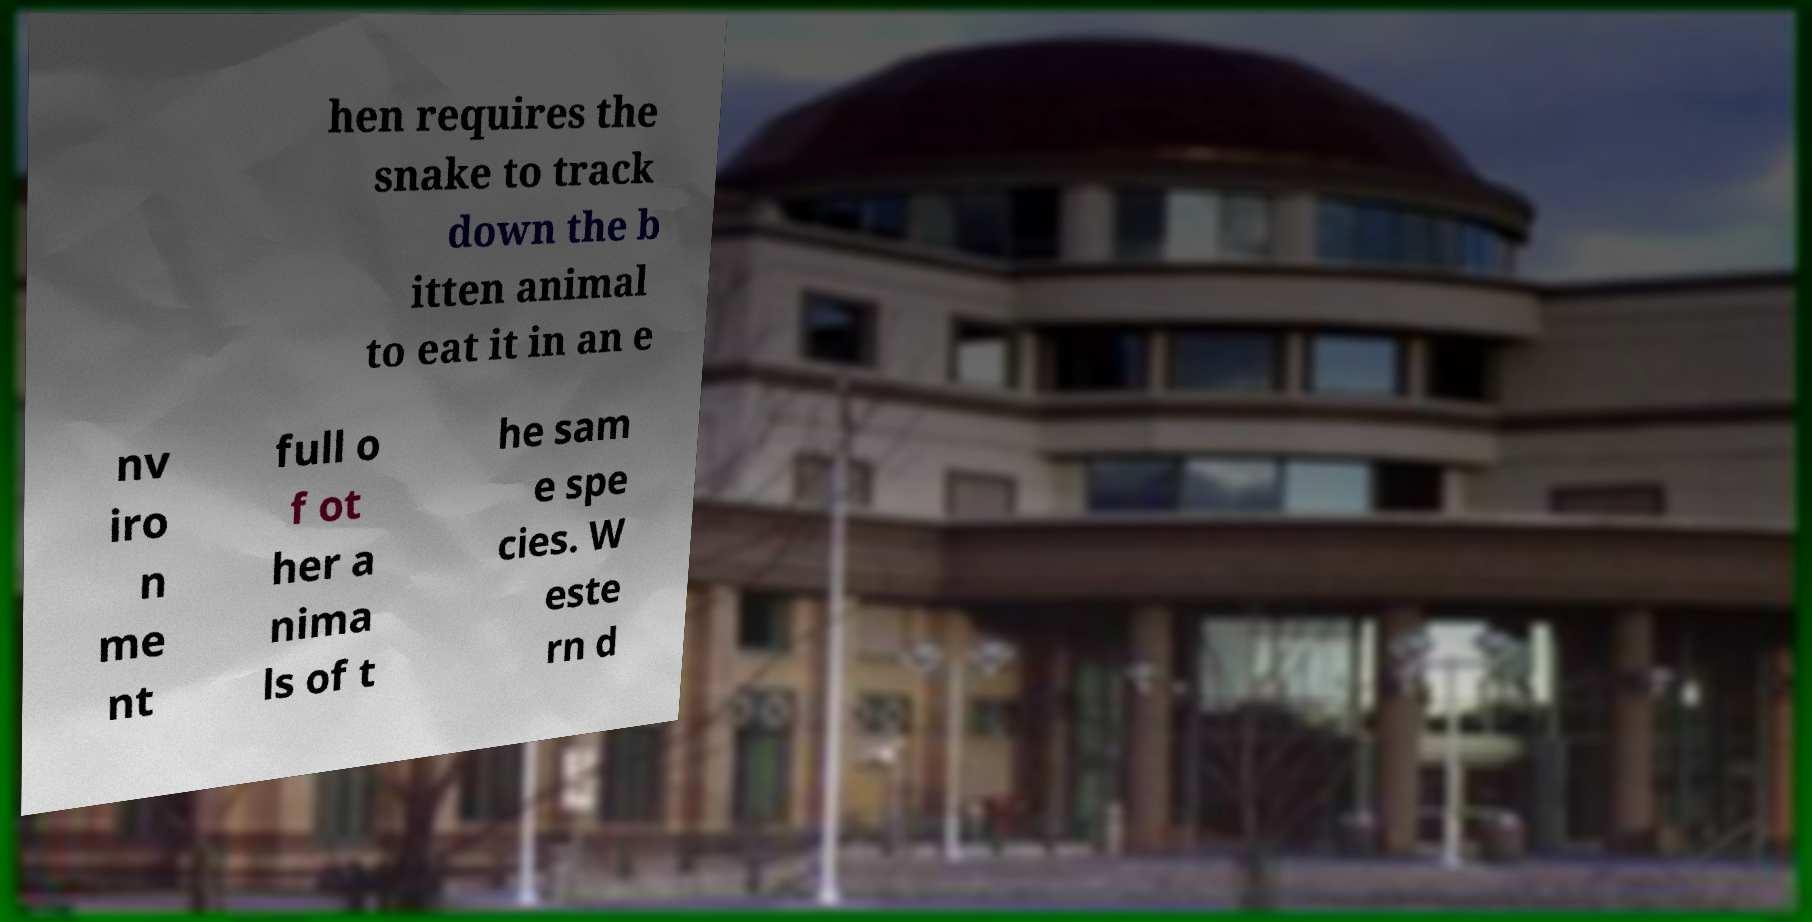I need the written content from this picture converted into text. Can you do that? hen requires the snake to track down the b itten animal to eat it in an e nv iro n me nt full o f ot her a nima ls of t he sam e spe cies. W este rn d 